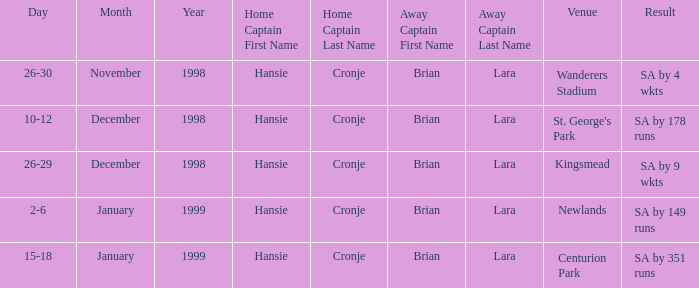Who is the away captain for Kingsmead? Brian Lara. 